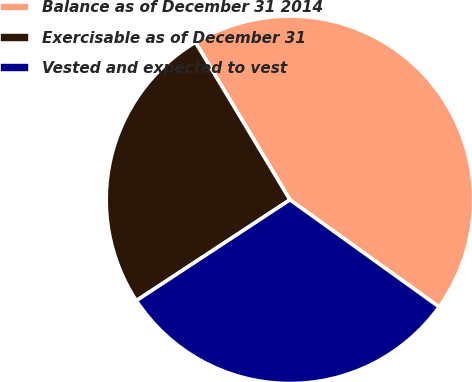Convert chart to OTSL. <chart><loc_0><loc_0><loc_500><loc_500><pie_chart><fcel>Balance as of December 31 2014<fcel>Exercisable as of December 31<fcel>Vested and expected to vest<nl><fcel>43.51%<fcel>25.65%<fcel>30.84%<nl></chart> 